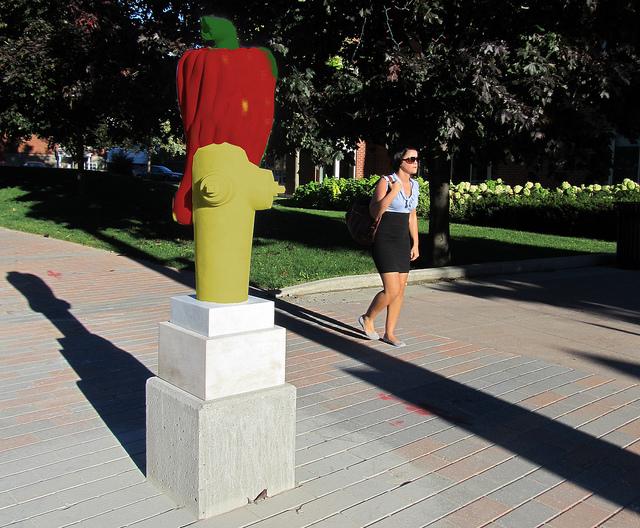What is the woman holding?
Write a very short answer. Purse. What color is the hydrant?
Be succinct. Yellow. What color is the women's shirt?
Give a very brief answer. Blue. Where was this photo taken?
Quick response, please. Park. What is the sculpture supposed to be?
Short answer required. Hydrant. How many poles surround the fire hydrant?
Give a very brief answer. 0. 